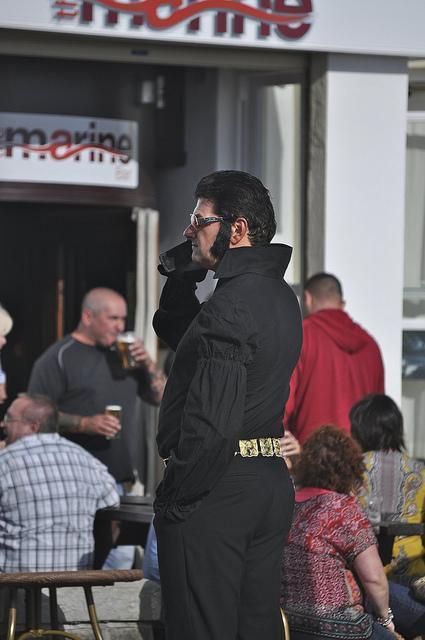The man in black is dressed like what star?
Pick the correct solution from the four options below to address the question.
Options: John travolta, tom cruise, elvis, danny devito. Elvis. 